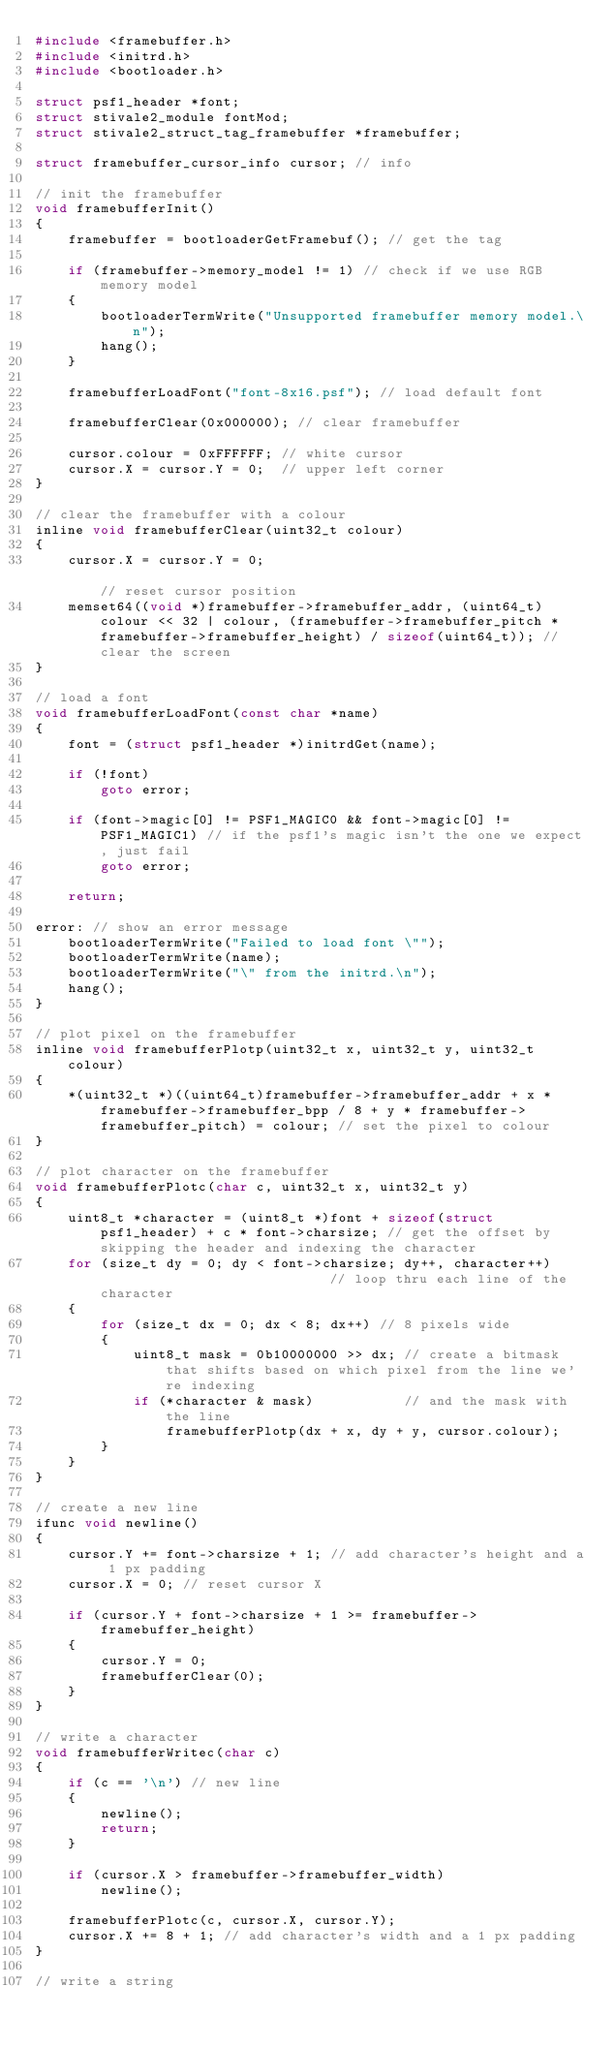Convert code to text. <code><loc_0><loc_0><loc_500><loc_500><_C_>#include <framebuffer.h>
#include <initrd.h>
#include <bootloader.h>

struct psf1_header *font;
struct stivale2_module fontMod;
struct stivale2_struct_tag_framebuffer *framebuffer;

struct framebuffer_cursor_info cursor; // info

// init the framebuffer
void framebufferInit()
{
    framebuffer = bootloaderGetFramebuf(); // get the tag

    if (framebuffer->memory_model != 1) // check if we use RGB memory model
    {
        bootloaderTermWrite("Unsupported framebuffer memory model.\n");
        hang();
    }

    framebufferLoadFont("font-8x16.psf"); // load default font

    framebufferClear(0x000000); // clear framebuffer

    cursor.colour = 0xFFFFFF; // white cursor
    cursor.X = cursor.Y = 0;  // upper left corner
}

// clear the framebuffer with a colour
inline void framebufferClear(uint32_t colour)
{
    cursor.X = cursor.Y = 0;                                                                                                                                                     // reset cursor position
    memset64((void *)framebuffer->framebuffer_addr, (uint64_t)colour << 32 | colour, (framebuffer->framebuffer_pitch * framebuffer->framebuffer_height) / sizeof(uint64_t)); // clear the screen
}

// load a font
void framebufferLoadFont(const char *name)
{
    font = (struct psf1_header *)initrdGet(name);

    if (!font)
        goto error;

    if (font->magic[0] != PSF1_MAGIC0 && font->magic[0] != PSF1_MAGIC1) // if the psf1's magic isn't the one we expect, just fail
        goto error;

    return;

error: // show an error message
    bootloaderTermWrite("Failed to load font \"");
    bootloaderTermWrite(name);
    bootloaderTermWrite("\" from the initrd.\n");
    hang();
}

// plot pixel on the framebuffer
inline void framebufferPlotp(uint32_t x, uint32_t y, uint32_t colour)
{
    *(uint32_t *)((uint64_t)framebuffer->framebuffer_addr + x * framebuffer->framebuffer_bpp / 8 + y * framebuffer->framebuffer_pitch) = colour; // set the pixel to colour
}

// plot character on the framebuffer
void framebufferPlotc(char c, uint32_t x, uint32_t y)
{
    uint8_t *character = (uint8_t *)font + sizeof(struct psf1_header) + c * font->charsize; // get the offset by skipping the header and indexing the character
    for (size_t dy = 0; dy < font->charsize; dy++, character++)                             // loop thru each line of the character
    {
        for (size_t dx = 0; dx < 8; dx++) // 8 pixels wide
        {
            uint8_t mask = 0b10000000 >> dx; // create a bitmask that shifts based on which pixel from the line we're indexing
            if (*character & mask)           // and the mask with the line
                framebufferPlotp(dx + x, dy + y, cursor.colour);
        }
    }
}

// create a new line
ifunc void newline()
{
    cursor.Y += font->charsize + 1; // add character's height and a 1 px padding
    cursor.X = 0; // reset cursor X

    if (cursor.Y + font->charsize + 1 >= framebuffer->framebuffer_height)
    {
        cursor.Y = 0;
        framebufferClear(0);
    }
}

// write a character
void framebufferWritec(char c)
{
    if (c == '\n') // new line
    {
        newline();
        return;
    }

    if (cursor.X > framebuffer->framebuffer_width)
        newline();

    framebufferPlotc(c, cursor.X, cursor.Y);
    cursor.X += 8 + 1; // add character's width and a 1 px padding
}

// write a string</code> 